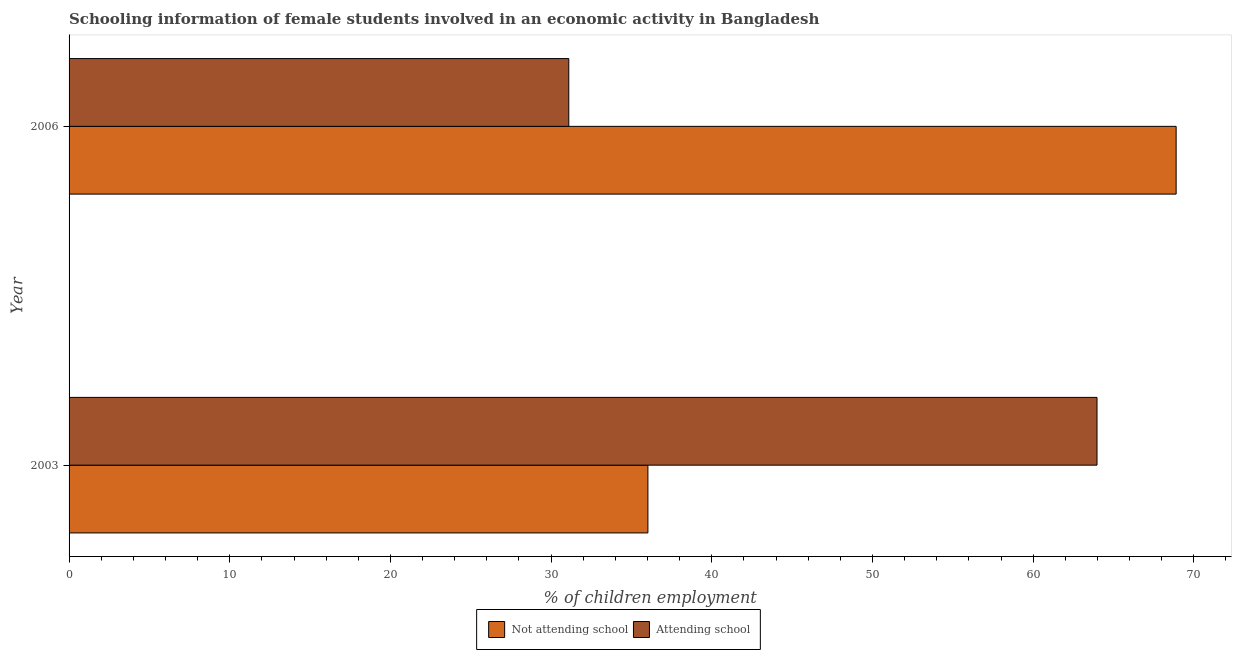Are the number of bars on each tick of the Y-axis equal?
Ensure brevity in your answer.  Yes. What is the label of the 1st group of bars from the top?
Provide a succinct answer. 2006. In how many cases, is the number of bars for a given year not equal to the number of legend labels?
Give a very brief answer. 0. What is the percentage of employed females who are attending school in 2003?
Provide a succinct answer. 63.98. Across all years, what is the maximum percentage of employed females who are not attending school?
Provide a short and direct response. 68.9. Across all years, what is the minimum percentage of employed females who are attending school?
Offer a terse response. 31.1. What is the total percentage of employed females who are not attending school in the graph?
Offer a terse response. 104.92. What is the difference between the percentage of employed females who are attending school in 2003 and that in 2006?
Ensure brevity in your answer.  32.88. What is the difference between the percentage of employed females who are not attending school in 2003 and the percentage of employed females who are attending school in 2006?
Offer a terse response. 4.92. What is the average percentage of employed females who are not attending school per year?
Your answer should be compact. 52.46. In the year 2003, what is the difference between the percentage of employed females who are not attending school and percentage of employed females who are attending school?
Your answer should be compact. -27.95. In how many years, is the percentage of employed females who are attending school greater than 70 %?
Make the answer very short. 0. What is the ratio of the percentage of employed females who are not attending school in 2003 to that in 2006?
Your answer should be very brief. 0.52. Is the difference between the percentage of employed females who are not attending school in 2003 and 2006 greater than the difference between the percentage of employed females who are attending school in 2003 and 2006?
Make the answer very short. No. What does the 2nd bar from the top in 2006 represents?
Offer a very short reply. Not attending school. What does the 1st bar from the bottom in 2003 represents?
Ensure brevity in your answer.  Not attending school. How many bars are there?
Make the answer very short. 4. Are all the bars in the graph horizontal?
Ensure brevity in your answer.  Yes. How many years are there in the graph?
Give a very brief answer. 2. What is the difference between two consecutive major ticks on the X-axis?
Offer a very short reply. 10. Does the graph contain grids?
Your answer should be compact. No. How many legend labels are there?
Offer a very short reply. 2. How are the legend labels stacked?
Offer a terse response. Horizontal. What is the title of the graph?
Make the answer very short. Schooling information of female students involved in an economic activity in Bangladesh. What is the label or title of the X-axis?
Your answer should be very brief. % of children employment. What is the % of children employment of Not attending school in 2003?
Provide a succinct answer. 36.02. What is the % of children employment of Attending school in 2003?
Your response must be concise. 63.98. What is the % of children employment of Not attending school in 2006?
Provide a succinct answer. 68.9. What is the % of children employment in Attending school in 2006?
Offer a very short reply. 31.1. Across all years, what is the maximum % of children employment of Not attending school?
Offer a very short reply. 68.9. Across all years, what is the maximum % of children employment of Attending school?
Your response must be concise. 63.98. Across all years, what is the minimum % of children employment of Not attending school?
Your answer should be very brief. 36.02. Across all years, what is the minimum % of children employment in Attending school?
Give a very brief answer. 31.1. What is the total % of children employment of Not attending school in the graph?
Your answer should be compact. 104.92. What is the total % of children employment of Attending school in the graph?
Your answer should be very brief. 95.08. What is the difference between the % of children employment of Not attending school in 2003 and that in 2006?
Your answer should be very brief. -32.88. What is the difference between the % of children employment in Attending school in 2003 and that in 2006?
Provide a short and direct response. 32.88. What is the difference between the % of children employment of Not attending school in 2003 and the % of children employment of Attending school in 2006?
Offer a terse response. 4.92. What is the average % of children employment in Not attending school per year?
Keep it short and to the point. 52.46. What is the average % of children employment in Attending school per year?
Give a very brief answer. 47.54. In the year 2003, what is the difference between the % of children employment of Not attending school and % of children employment of Attending school?
Provide a short and direct response. -27.95. In the year 2006, what is the difference between the % of children employment in Not attending school and % of children employment in Attending school?
Your answer should be very brief. 37.8. What is the ratio of the % of children employment of Not attending school in 2003 to that in 2006?
Keep it short and to the point. 0.52. What is the ratio of the % of children employment in Attending school in 2003 to that in 2006?
Ensure brevity in your answer.  2.06. What is the difference between the highest and the second highest % of children employment in Not attending school?
Give a very brief answer. 32.88. What is the difference between the highest and the second highest % of children employment of Attending school?
Keep it short and to the point. 32.88. What is the difference between the highest and the lowest % of children employment of Not attending school?
Ensure brevity in your answer.  32.88. What is the difference between the highest and the lowest % of children employment of Attending school?
Keep it short and to the point. 32.88. 